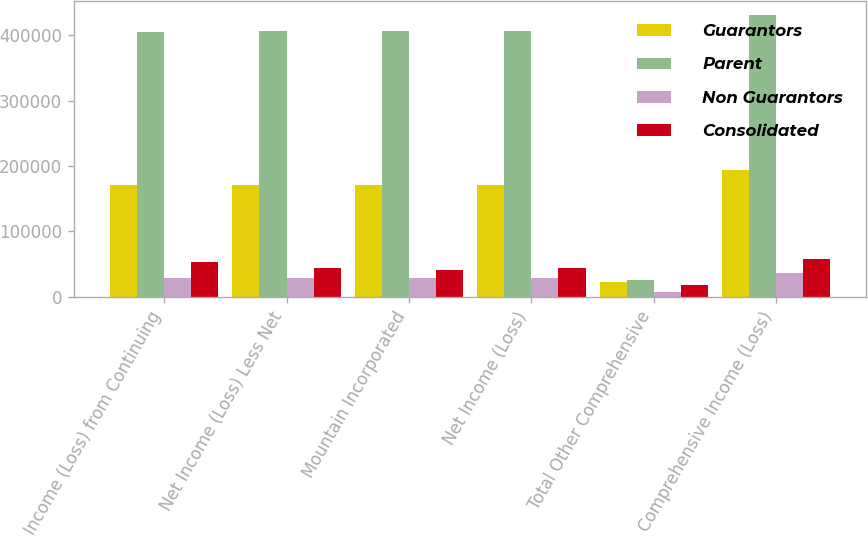Convert chart to OTSL. <chart><loc_0><loc_0><loc_500><loc_500><stacked_bar_chart><ecel><fcel>Income (Loss) from Continuing<fcel>Net Income (Loss) Less Net<fcel>Mountain Incorporated<fcel>Net Income (Loss)<fcel>Total Other Comprehensive<fcel>Comprehensive Income (Loss)<nl><fcel>Guarantors<fcel>171708<fcel>171708<fcel>171708<fcel>171708<fcel>22517<fcel>194225<nl><fcel>Parent<fcel>405262<fcel>405692<fcel>405692<fcel>405692<fcel>25209<fcel>430901<nl><fcel>Non Guarantors<fcel>28750<fcel>28750<fcel>28750<fcel>28750<fcel>8012<fcel>36762<nl><fcel>Consolidated<fcel>52821<fcel>43732<fcel>40606<fcel>43732<fcel>18488<fcel>58425<nl></chart> 